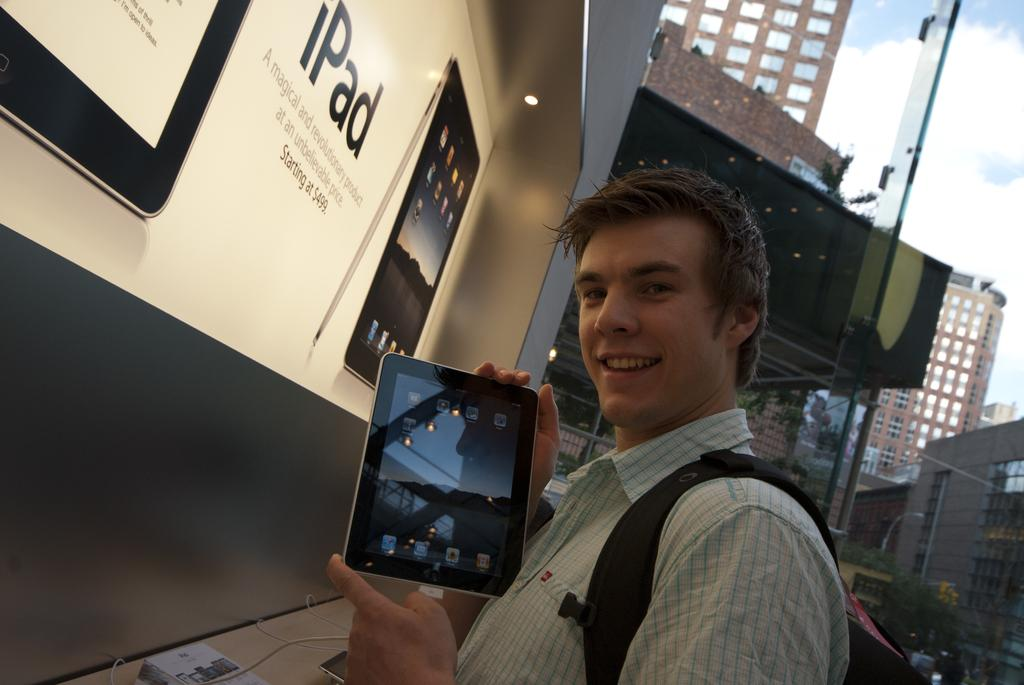Who is present in the image? There is a man in the image. What is the man holding in the image? The man is holding a tab with his hands. What is the man's facial expression in the image? The man is smiling in the image. What can be seen in the background of the image? There are buildings and the sky visible in the background of the image. How does the man's digestion process appear in the image? There is no indication of the man's digestion process in the image; it only shows him holding a tab and smiling. 